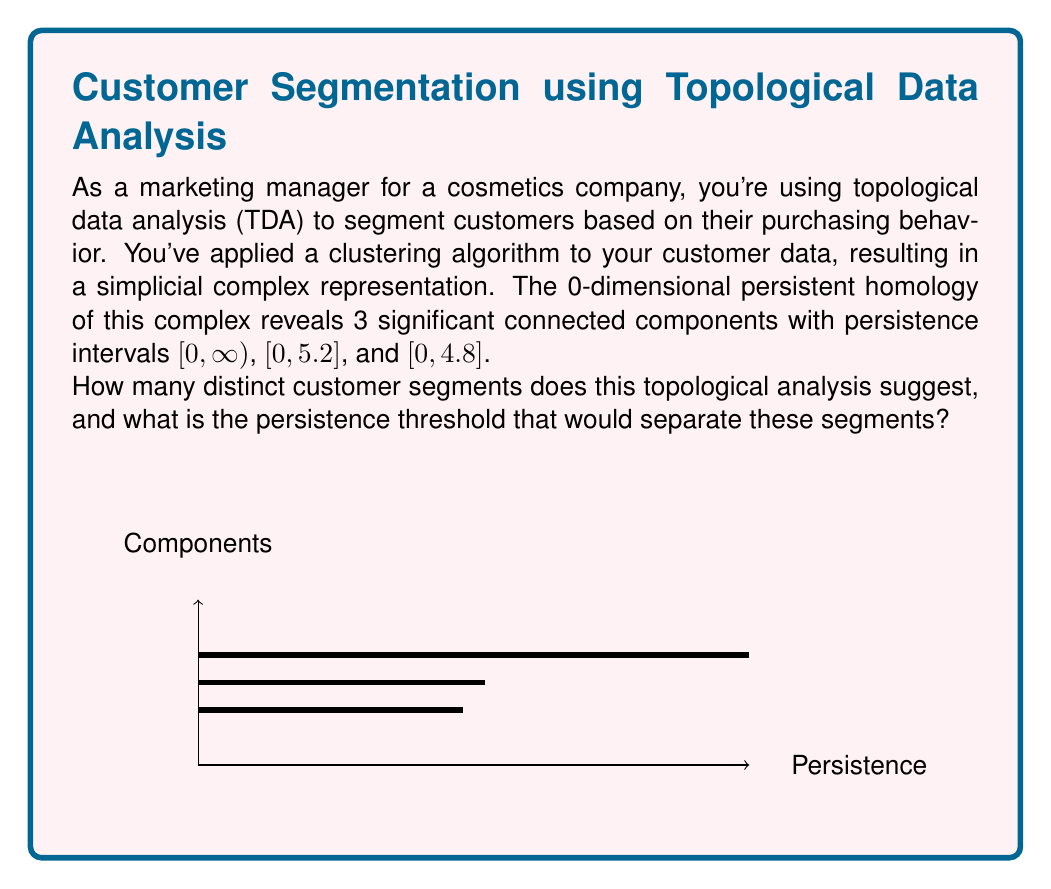Could you help me with this problem? To answer this question, we need to analyze the persistent homology data:

1. In persistent homology, each interval [birth, death) represents a topological feature (in this case, connected components).

2. The interval [0, ∞) represents a feature that persists throughout the entire filtration, indicating a stable component.

3. The other two intervals, [0, 5.2] and [0, 4.8], represent less persistent features.

4. To determine the number of distinct segments, we need to choose a persistence threshold that separates significant features from noise.

5. The persistence of a feature is calculated as: death - birth.
   For [0, 5.2]: persistence = 5.2 - 0 = 5.2
   For [0, 4.8]: persistence = 4.8 - 0 = 4.8

6. To separate these features, we need to choose a threshold below 4.8, as this will preserve all three components.

7. A common practice is to choose the midpoint between the lowest significant persistence and the highest noise persistence. In this case, there's no clear noise, so we can choose a threshold just below 4.8.

8. Let's select 4.7 as our threshold. This preserves all three components while allowing for a small buffer.

Therefore, this topological analysis suggests 3 distinct customer segments, with a persistence threshold of 4.7 to separate these segments.
Answer: 3 segments; threshold = 4.7 